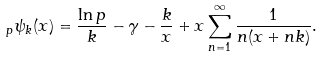<formula> <loc_0><loc_0><loc_500><loc_500>_ { p } \psi _ { k } ( x ) = \frac { \ln p } { k } - \gamma - \frac { k } { x } + x \sum _ { n = 1 } ^ { \infty } \frac { 1 } { n ( x + n k ) } .</formula> 